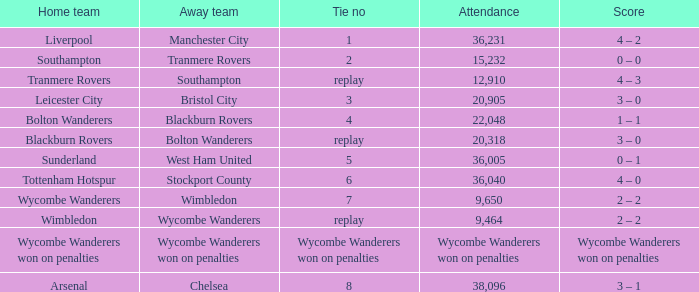What was the attendance for the game where the away team was Stockport County? 36040.0. 